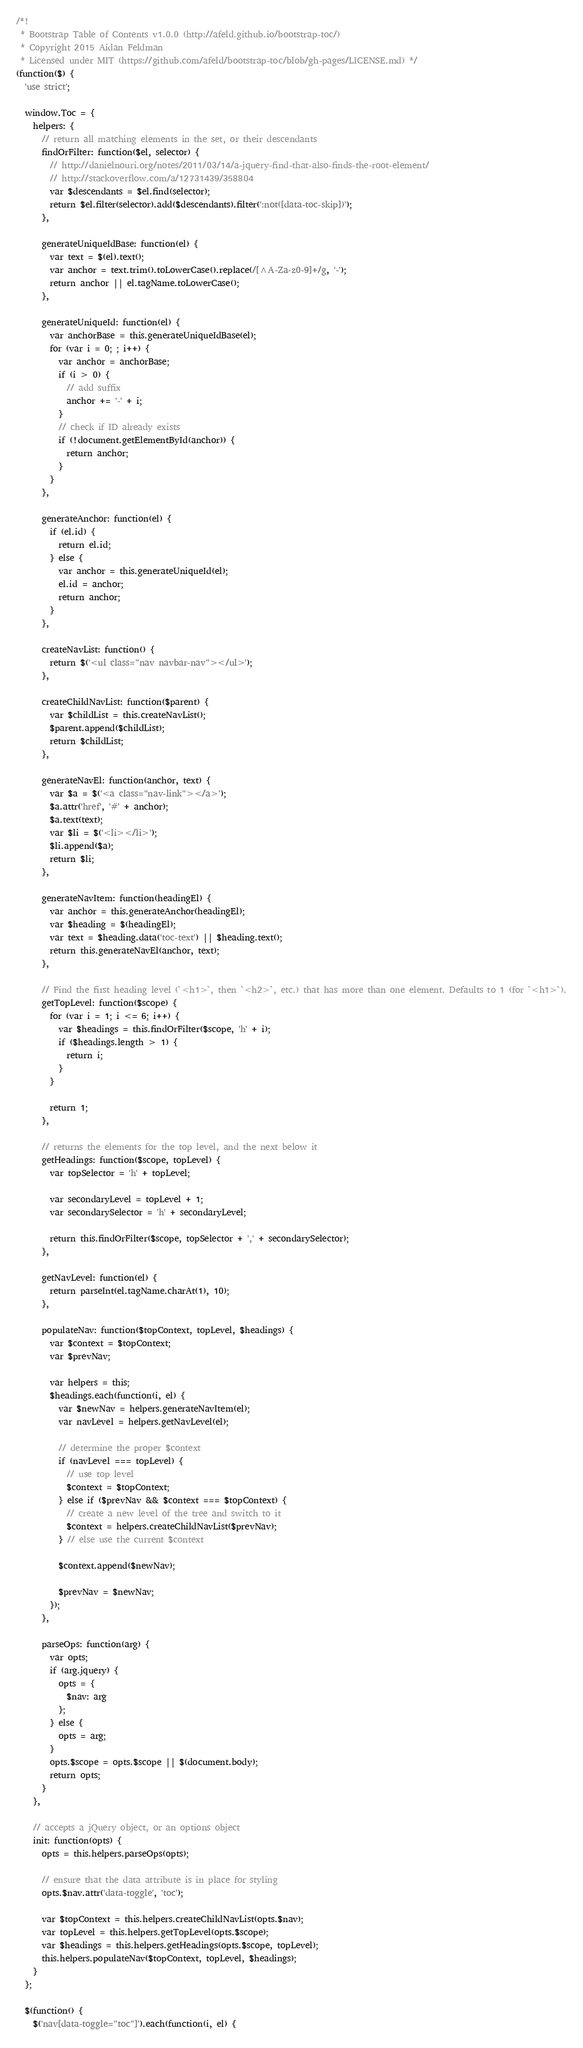Convert code to text. <code><loc_0><loc_0><loc_500><loc_500><_JavaScript_>/*!
 * Bootstrap Table of Contents v1.0.0 (http://afeld.github.io/bootstrap-toc/)
 * Copyright 2015 Aidan Feldman
 * Licensed under MIT (https://github.com/afeld/bootstrap-toc/blob/gh-pages/LICENSE.md) */
(function($) {
  'use strict';

  window.Toc = {
    helpers: {
      // return all matching elements in the set, or their descendants
      findOrFilter: function($el, selector) {
        // http://danielnouri.org/notes/2011/03/14/a-jquery-find-that-also-finds-the-root-element/
        // http://stackoverflow.com/a/12731439/358804
        var $descendants = $el.find(selector);
        return $el.filter(selector).add($descendants).filter(':not([data-toc-skip])');
      },

      generateUniqueIdBase: function(el) {
        var text = $(el).text();
        var anchor = text.trim().toLowerCase().replace(/[^A-Za-z0-9]+/g, '-');
        return anchor || el.tagName.toLowerCase();
      },

      generateUniqueId: function(el) {
        var anchorBase = this.generateUniqueIdBase(el);
        for (var i = 0; ; i++) {
          var anchor = anchorBase;
          if (i > 0) {
            // add suffix
            anchor += '-' + i;
          }
          // check if ID already exists
          if (!document.getElementById(anchor)) {
            return anchor;
          }
        }
      },

      generateAnchor: function(el) {
        if (el.id) {
          return el.id;
        } else {
          var anchor = this.generateUniqueId(el);
          el.id = anchor;
          return anchor;
        }
      },

      createNavList: function() {
        return $('<ul class="nav navbar-nav"></ul>');
      },

      createChildNavList: function($parent) {
        var $childList = this.createNavList();
        $parent.append($childList);
        return $childList;
      },

      generateNavEl: function(anchor, text) {
        var $a = $('<a class="nav-link"></a>');
        $a.attr('href', '#' + anchor);
        $a.text(text);
        var $li = $('<li></li>');
        $li.append($a);
        return $li;
      },

      generateNavItem: function(headingEl) {
        var anchor = this.generateAnchor(headingEl);
        var $heading = $(headingEl);
        var text = $heading.data('toc-text') || $heading.text();
        return this.generateNavEl(anchor, text);
      },

      // Find the first heading level (`<h1>`, then `<h2>`, etc.) that has more than one element. Defaults to 1 (for `<h1>`).
      getTopLevel: function($scope) {
        for (var i = 1; i <= 6; i++) {
          var $headings = this.findOrFilter($scope, 'h' + i);
          if ($headings.length > 1) {
            return i;
          }
        }

        return 1;
      },

      // returns the elements for the top level, and the next below it
      getHeadings: function($scope, topLevel) {
        var topSelector = 'h' + topLevel;

        var secondaryLevel = topLevel + 1;
        var secondarySelector = 'h' + secondaryLevel;

        return this.findOrFilter($scope, topSelector + ',' + secondarySelector);
      },

      getNavLevel: function(el) {
        return parseInt(el.tagName.charAt(1), 10);
      },

      populateNav: function($topContext, topLevel, $headings) {
        var $context = $topContext;
        var $prevNav;

        var helpers = this;
        $headings.each(function(i, el) {
          var $newNav = helpers.generateNavItem(el);
          var navLevel = helpers.getNavLevel(el);

          // determine the proper $context
          if (navLevel === topLevel) {
            // use top level
            $context = $topContext;
          } else if ($prevNav && $context === $topContext) {
            // create a new level of the tree and switch to it
            $context = helpers.createChildNavList($prevNav);
          } // else use the current $context

          $context.append($newNav);

          $prevNav = $newNav;
        });
      },

      parseOps: function(arg) {
        var opts;
        if (arg.jquery) {
          opts = {
            $nav: arg
          };
        } else {
          opts = arg;
        }
        opts.$scope = opts.$scope || $(document.body);
        return opts;
      }
    },

    // accepts a jQuery object, or an options object
    init: function(opts) {
      opts = this.helpers.parseOps(opts);

      // ensure that the data attribute is in place for styling
      opts.$nav.attr('data-toggle', 'toc');

      var $topContext = this.helpers.createChildNavList(opts.$nav);
      var topLevel = this.helpers.getTopLevel(opts.$scope);
      var $headings = this.helpers.getHeadings(opts.$scope, topLevel);
      this.helpers.populateNav($topContext, topLevel, $headings);
    }
  };

  $(function() {
    $('nav[data-toggle="toc"]').each(function(i, el) {</code> 